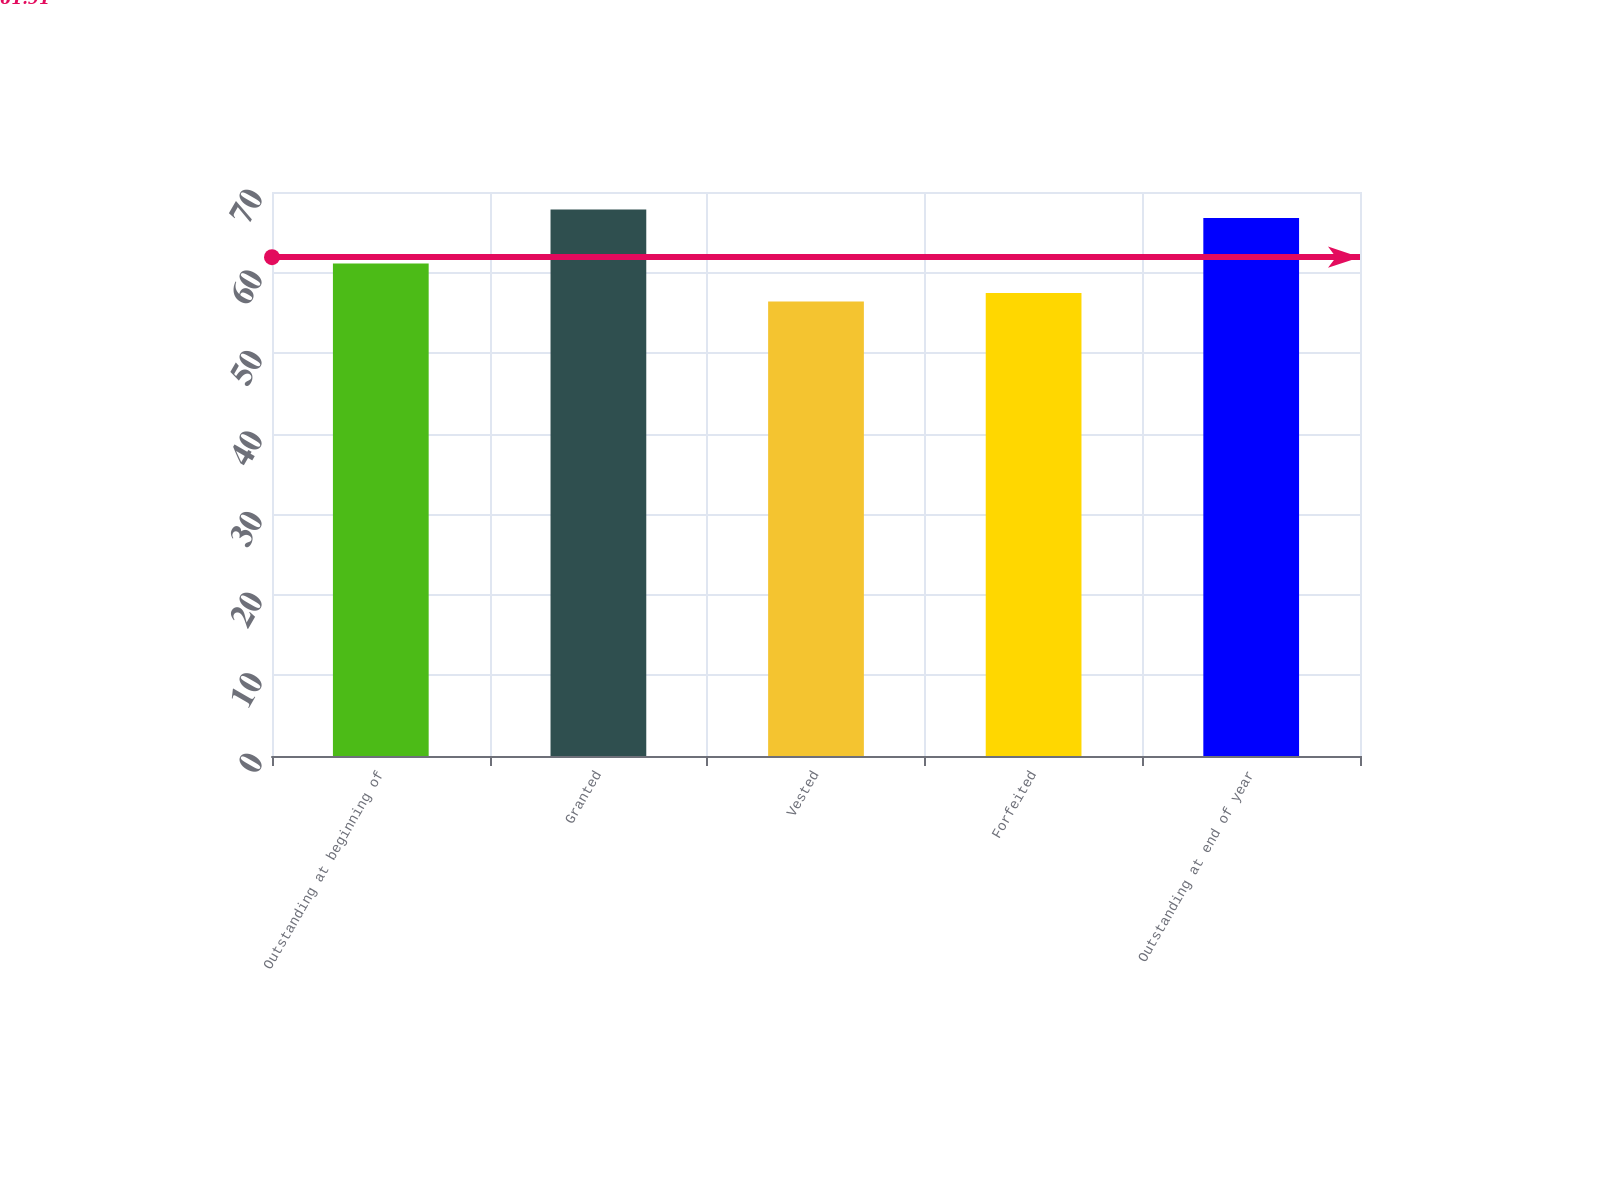Convert chart to OTSL. <chart><loc_0><loc_0><loc_500><loc_500><bar_chart><fcel>Outstanding at beginning of<fcel>Granted<fcel>Vested<fcel>Forfeited<fcel>Outstanding at end of year<nl><fcel>61.12<fcel>67.82<fcel>56.4<fcel>57.46<fcel>66.76<nl></chart> 